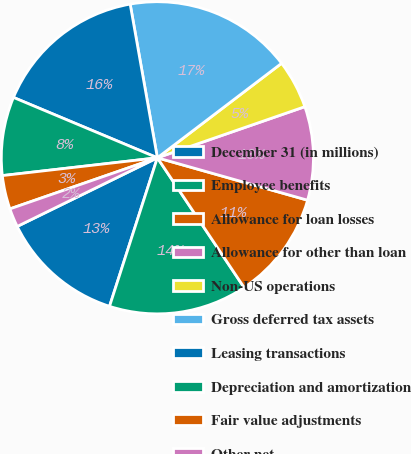<chart> <loc_0><loc_0><loc_500><loc_500><pie_chart><fcel>December 31 (in millions)<fcel>Employee benefits<fcel>Allowance for loan losses<fcel>Allowance for other than loan<fcel>Non-US operations<fcel>Gross deferred tax assets<fcel>Leasing transactions<fcel>Depreciation and amortization<fcel>Fair value adjustments<fcel>Other net<nl><fcel>12.79%<fcel>14.34%<fcel>11.24%<fcel>9.69%<fcel>5.04%<fcel>17.44%<fcel>15.89%<fcel>8.14%<fcel>3.49%<fcel>1.94%<nl></chart> 